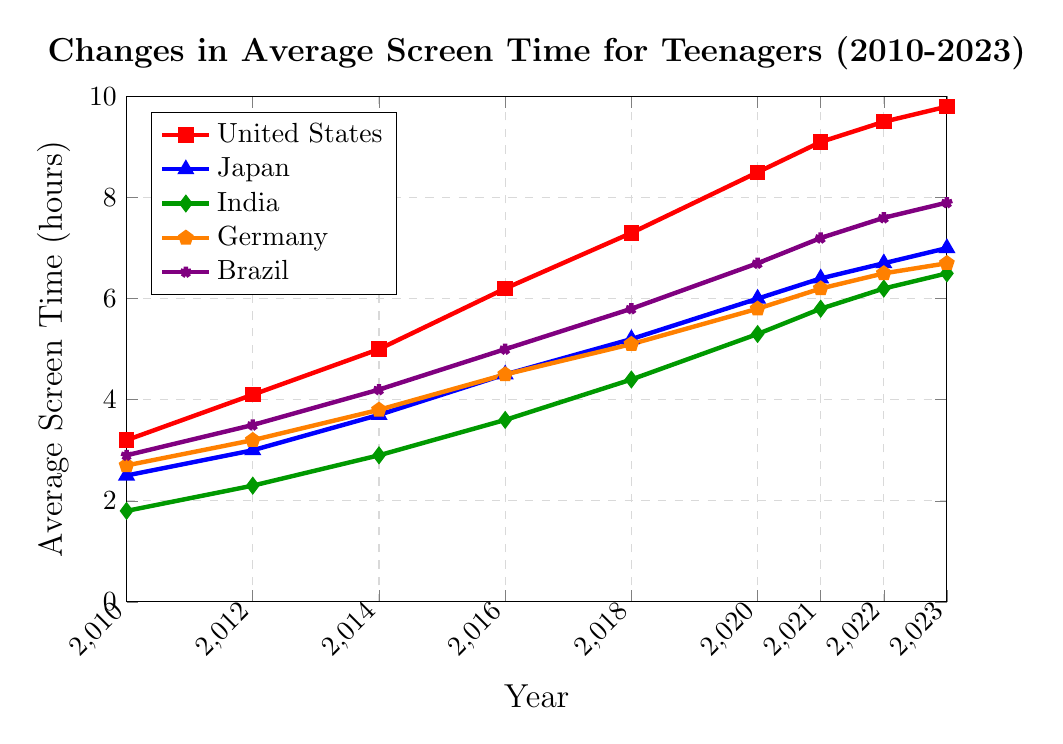What's the overall trend in screen time for teenagers in all five countries from 2010 to 2023? From the figure, we can observe that the screen time in all five countries shows an increasing trend. Each line representing a country slopes upward from 2010 to 2023, indicating a rise in screen time over the years.
Answer: Increasing Between which years did the United States see the most significant rise in average screen time? Look at the slope of the line for the United States (red) and identify the steepest section. The steepest rise appears between 2018 (7.3 hours) and 2020 (8.5 hours), indicating the most significant rise.
Answer: 2018 to 2020 Which country had the highest screen time in 2023? By identifying the highest point on the y-axis for 2023, we see that the United States (red line) has the highest average screen time at 9.8 hours.
Answer: United States How much did the average screen time for teenagers in Japan increase from 2010 to 2023? Subtract the screen time for Japan in 2010 from that in 2023: 7.0 hours (2023) - 2.5 hours (2010) = 4.5 hours.
Answer: 4.5 hours In which year did Brazil surpass Germany in average screen time, and by how much? Identify the points where Brazil (violet line) first exceeds Germany (orange line). This occurs in 2014, where Brazil has 4.2 hours, and Germany has 3.8 hours. The difference is 4.2 - 3.8 = 0.4 hours.
Answer: 2014, 0.4 hours Which country had the lowest screen time in 2018, and what was the value? Look for the lowest point on the y-axis in 2018. India (green line) has the lowest value at 4.4 hours.
Answer: India, 4.4 hours How does the average screen time in Germany in 2023 compare to that in 2012? The screen time for Germany in 2023 is 6.7 hours, and in 2012, it was 3.2 hours. The difference is 6.7 - 3.2 = 3.5 hours, indicating an increase.
Answer: Increased by 3.5 hours What's the average change in screen time per year for teenagers in India from 2010 to 2023? Calculate the total change in screen time for India: 6.5 (2023) - 1.8 (2010) = 4.7 hours over 13 years. The average change per year is 4.7 / 13 ≈ 0.36 hours.
Answer: 0.36 hours per year Was there any year when the average screen time for teenagers decreased in any country? Check each line for any downward slopes. All trends appear to be consistently upward without any decreases across the years for all countries.
Answer: No Which two countries had the most similar screen times in 2021? Compare the values for each country in 2021. Germany and Japan have almost similar screen times, with Germany at 6.2 hours and Japan at 6.4 hours.
Answer: Germany and Japan 